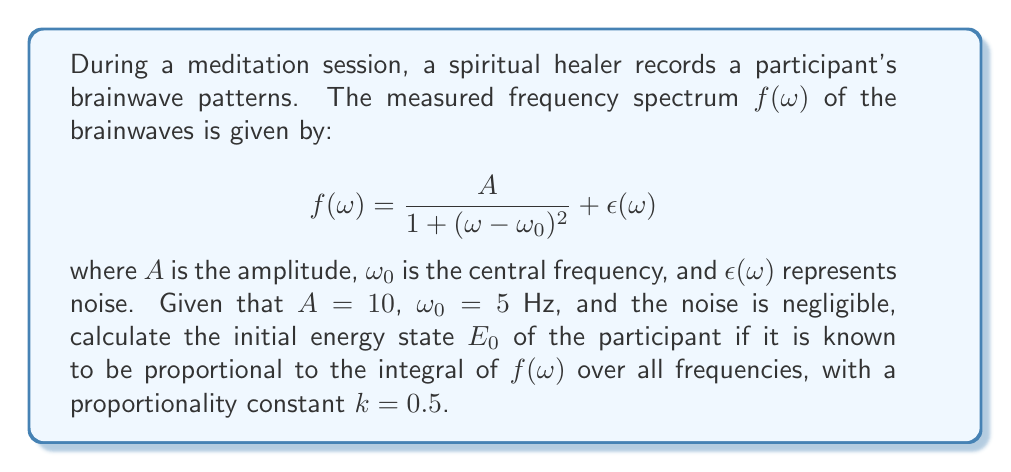Give your solution to this math problem. To solve this inverse problem and find the initial energy state, we need to follow these steps:

1) The energy state $E_0$ is proportional to the integral of $f(\omega)$ over all frequencies:

   $$E_0 = k \int_{-\infty}^{\infty} f(\omega) d\omega$$

2) Substituting the given function and ignoring the noise term:

   $$E_0 = 0.5 \int_{-\infty}^{\infty} \frac{10}{1 + (\omega - 5)^2} d\omega$$

3) This integral is of the form:

   $$\int_{-\infty}^{\infty} \frac{a}{1 + (x - b)^2} dx = a\pi$$

   where $a = 10$ and $b = 5$ in our case.

4) Therefore, we can directly write:

   $$E_0 = 0.5 \cdot 10\pi = 5\pi$$

Thus, the initial energy state of the participant is $5\pi$.
Answer: $5\pi$ 